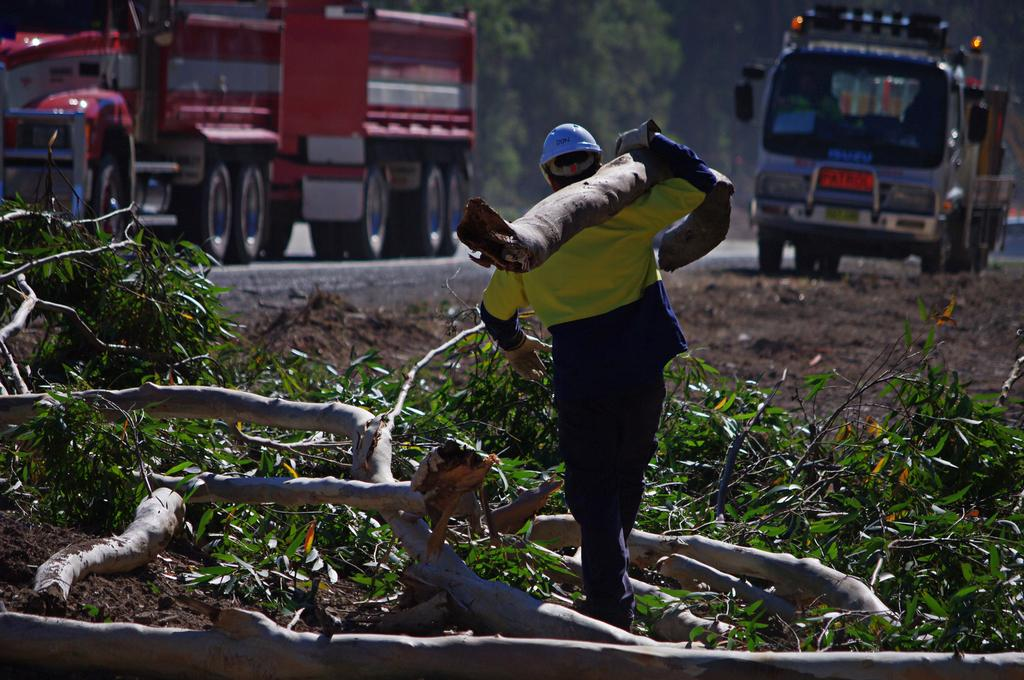What type of natural elements can be seen in the image? There are trees, branches, and leaves visible in the image. What else can be seen in the image besides natural elements? There are vehicles and a man wearing a helmet in the image. What is the man carrying in the image? The man is carrying a branch on his shoulder. What arithmetic problem is the man solving while carrying the branch in the image? There is no indication in the image that the man is solving an arithmetic problem; he is simply carrying a branch on his shoulder. 